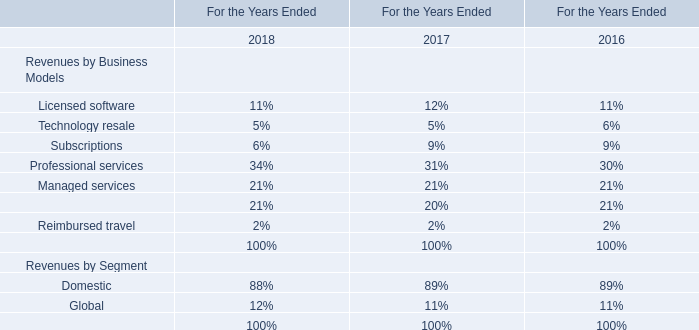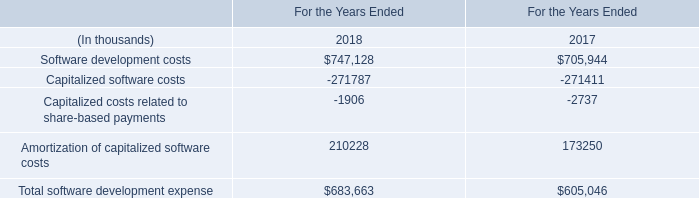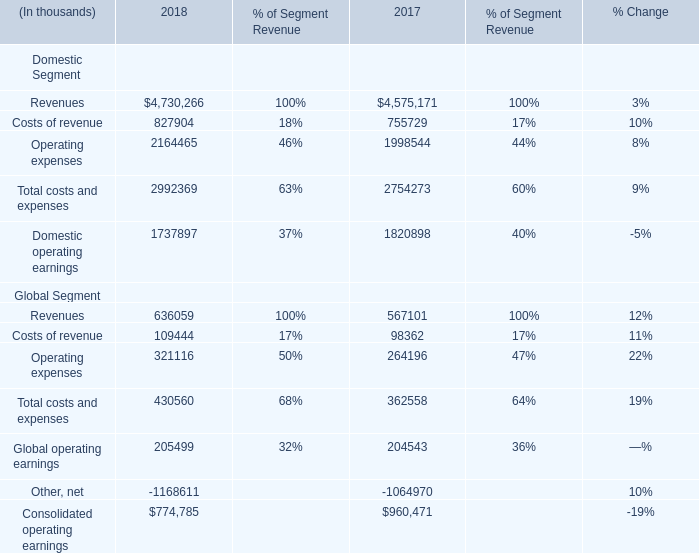What's the growth rate of Consolidated operating earnings in 2018? 
Computations: ((774785 - 960471) / 960471)
Answer: -0.19333. 